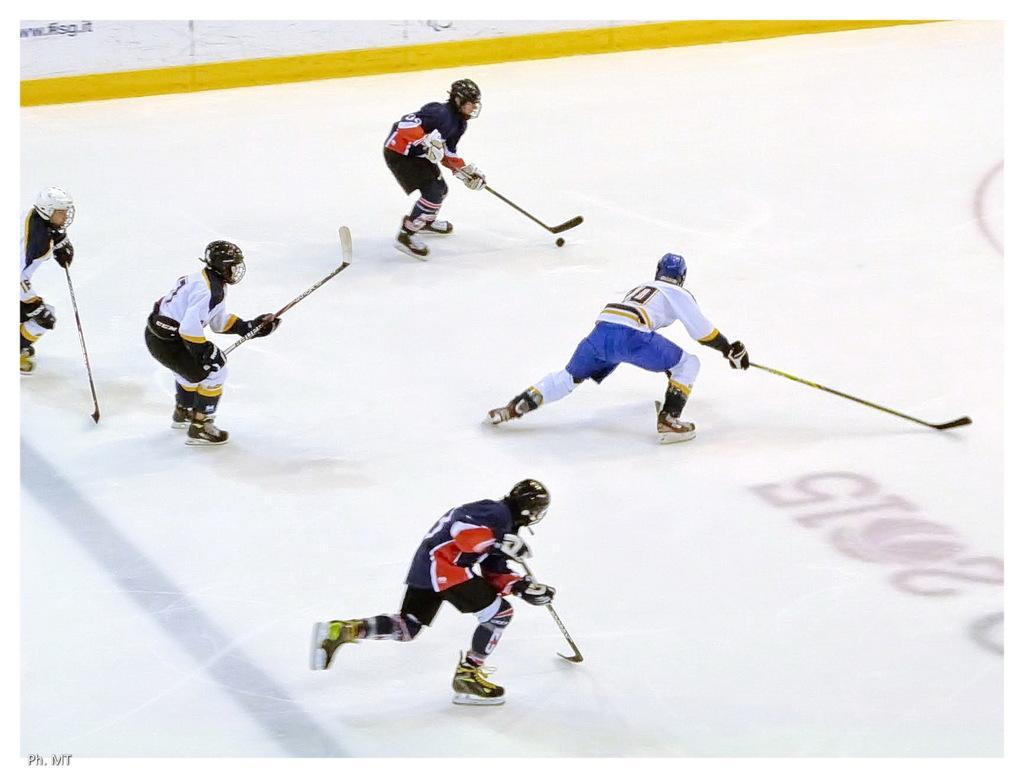Describe this image in one or two sentences. In this picture I can observe some players playing ice hockey. All of them are wearing helmets on their heads. 